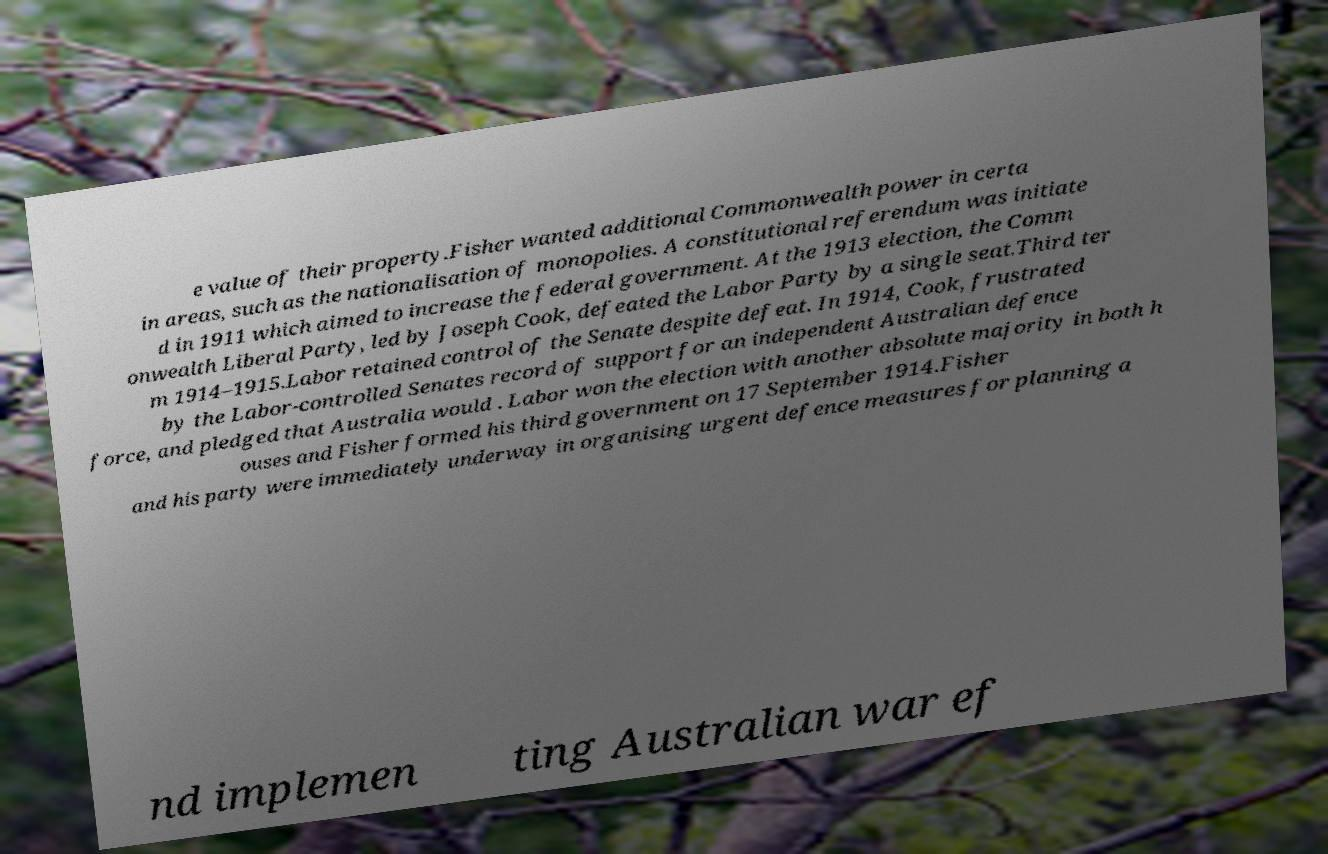Please read and relay the text visible in this image. What does it say? e value of their property.Fisher wanted additional Commonwealth power in certa in areas, such as the nationalisation of monopolies. A constitutional referendum was initiate d in 1911 which aimed to increase the federal government. At the 1913 election, the Comm onwealth Liberal Party, led by Joseph Cook, defeated the Labor Party by a single seat.Third ter m 1914–1915.Labor retained control of the Senate despite defeat. In 1914, Cook, frustrated by the Labor-controlled Senates record of support for an independent Australian defence force, and pledged that Australia would . Labor won the election with another absolute majority in both h ouses and Fisher formed his third government on 17 September 1914.Fisher and his party were immediately underway in organising urgent defence measures for planning a nd implemen ting Australian war ef 